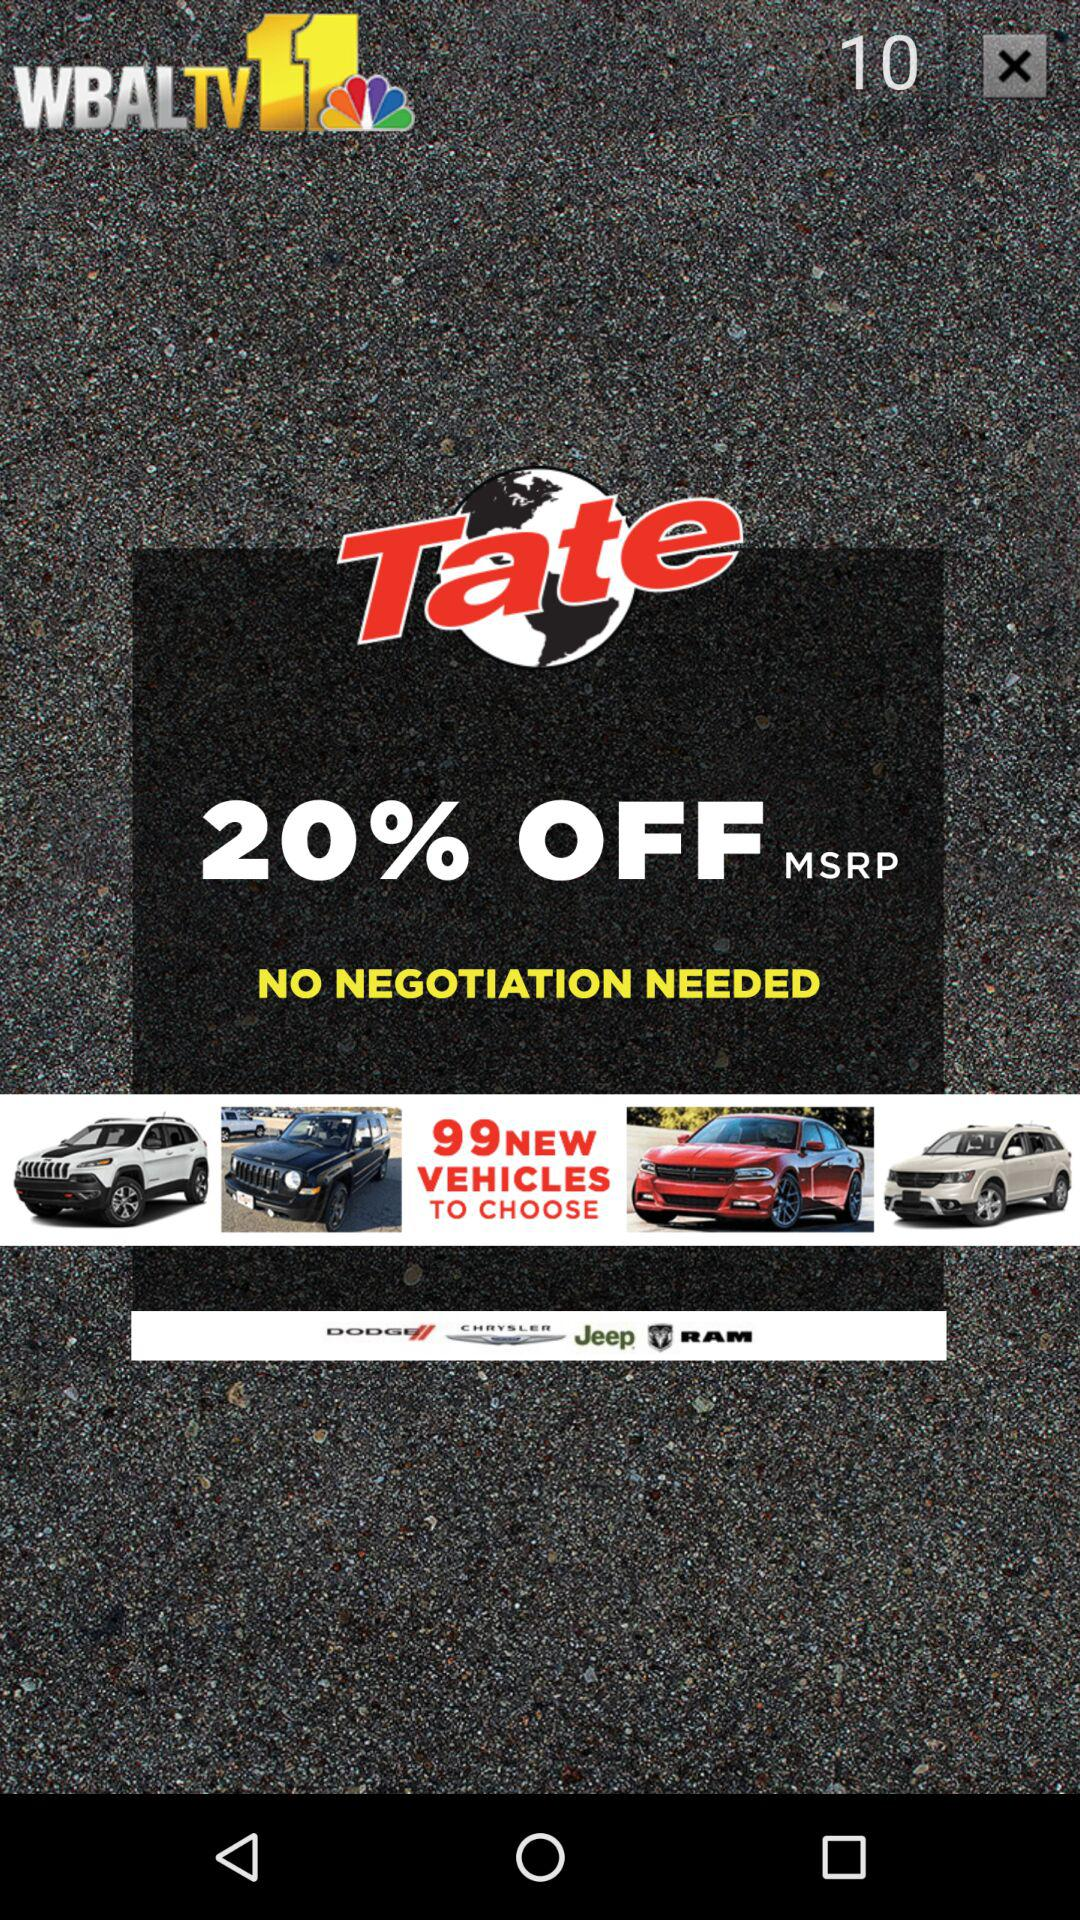How many vehicles are advertised?
Answer the question using a single word or phrase. 99 